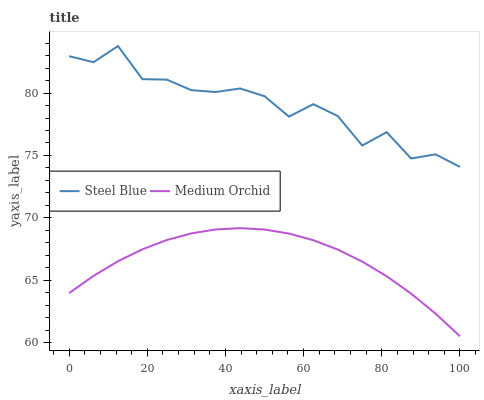Does Medium Orchid have the minimum area under the curve?
Answer yes or no. Yes. Does Steel Blue have the maximum area under the curve?
Answer yes or no. Yes. Does Steel Blue have the minimum area under the curve?
Answer yes or no. No. Is Medium Orchid the smoothest?
Answer yes or no. Yes. Is Steel Blue the roughest?
Answer yes or no. Yes. Is Steel Blue the smoothest?
Answer yes or no. No. Does Medium Orchid have the lowest value?
Answer yes or no. Yes. Does Steel Blue have the lowest value?
Answer yes or no. No. Does Steel Blue have the highest value?
Answer yes or no. Yes. Is Medium Orchid less than Steel Blue?
Answer yes or no. Yes. Is Steel Blue greater than Medium Orchid?
Answer yes or no. Yes. Does Medium Orchid intersect Steel Blue?
Answer yes or no. No. 